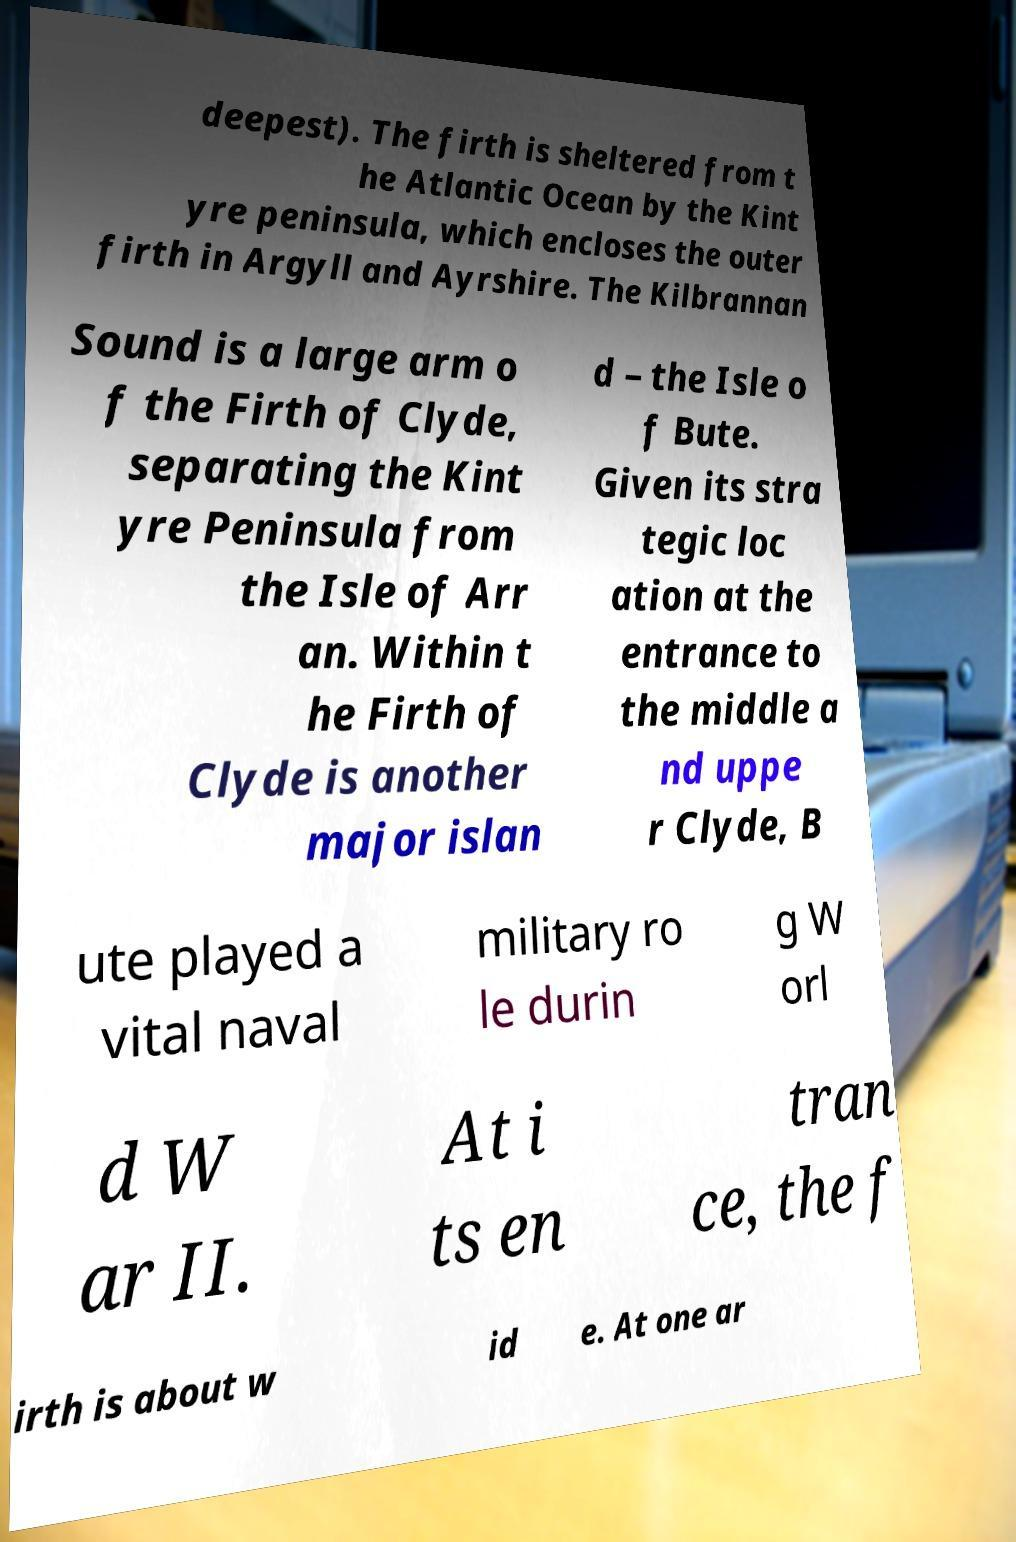Please read and relay the text visible in this image. What does it say? deepest). The firth is sheltered from t he Atlantic Ocean by the Kint yre peninsula, which encloses the outer firth in Argyll and Ayrshire. The Kilbrannan Sound is a large arm o f the Firth of Clyde, separating the Kint yre Peninsula from the Isle of Arr an. Within t he Firth of Clyde is another major islan d – the Isle o f Bute. Given its stra tegic loc ation at the entrance to the middle a nd uppe r Clyde, B ute played a vital naval military ro le durin g W orl d W ar II. At i ts en tran ce, the f irth is about w id e. At one ar 